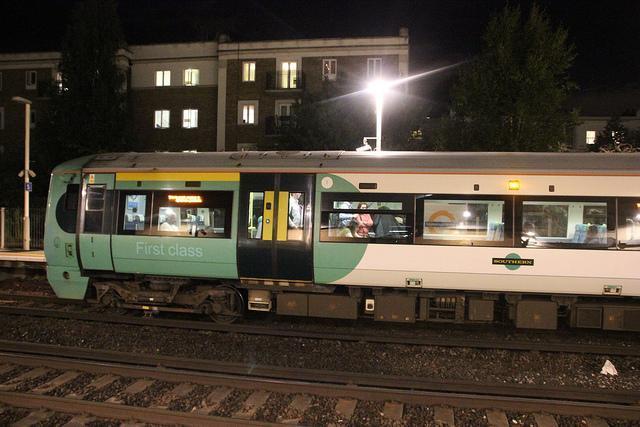How many of the people sitting have a laptop on there lap?
Give a very brief answer. 0. 